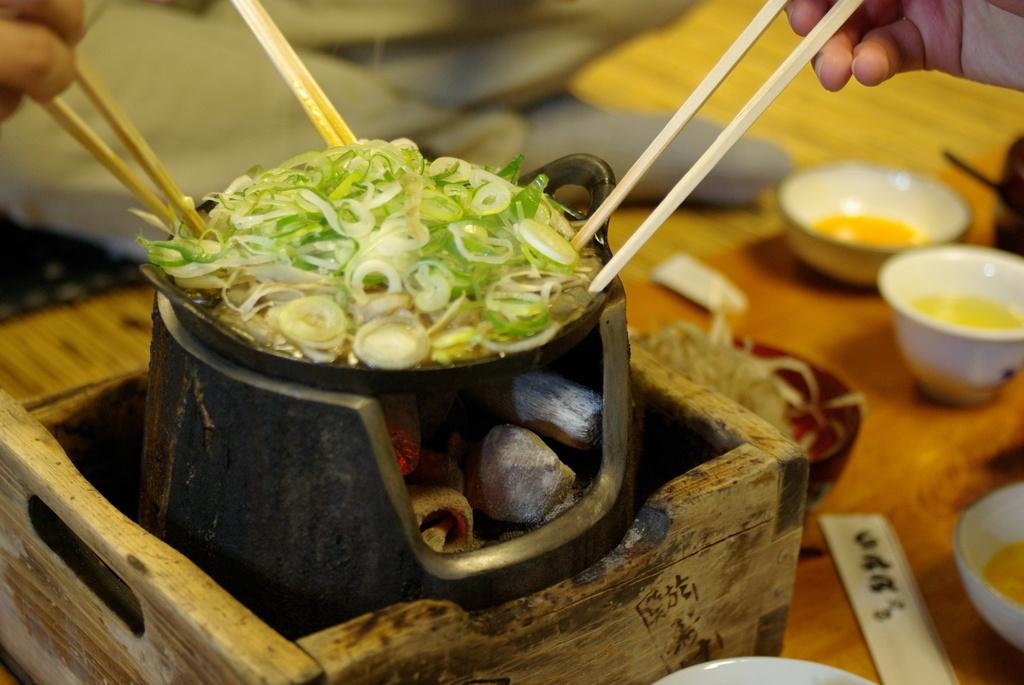What is the main piece of furniture in the image? There is a table in the image. What is placed on the table? There are bowls and a box on the table. What is inside the box? There is food in the box, and specifically, a bowl with food and charcoal in the box. What are the persons holding in the image? The persons are holding chopsticks. What type of nerve can be seen in the image? There is no nerve visible in the image; it features a table with bowls, a box, and persons holding chopsticks. 